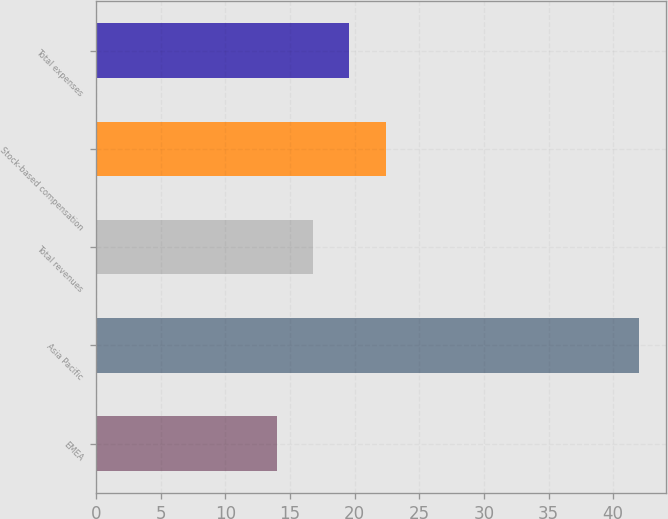Convert chart. <chart><loc_0><loc_0><loc_500><loc_500><bar_chart><fcel>EMEA<fcel>Asia Pacific<fcel>Total revenues<fcel>Stock-based compensation<fcel>Total expenses<nl><fcel>14<fcel>42<fcel>16.8<fcel>22.4<fcel>19.6<nl></chart> 